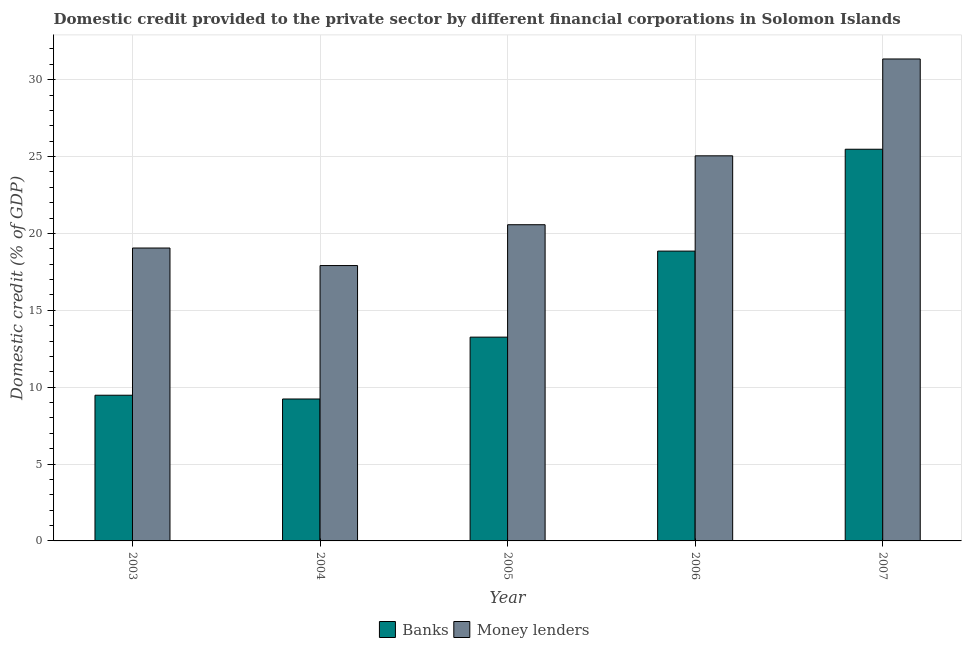How many groups of bars are there?
Offer a terse response. 5. How many bars are there on the 4th tick from the left?
Ensure brevity in your answer.  2. In how many cases, is the number of bars for a given year not equal to the number of legend labels?
Offer a terse response. 0. What is the domestic credit provided by money lenders in 2003?
Your answer should be compact. 19.05. Across all years, what is the maximum domestic credit provided by money lenders?
Give a very brief answer. 31.35. Across all years, what is the minimum domestic credit provided by banks?
Keep it short and to the point. 9.23. What is the total domestic credit provided by money lenders in the graph?
Provide a short and direct response. 113.93. What is the difference between the domestic credit provided by money lenders in 2004 and that in 2006?
Keep it short and to the point. -7.14. What is the difference between the domestic credit provided by money lenders in 2004 and the domestic credit provided by banks in 2007?
Offer a very short reply. -13.44. What is the average domestic credit provided by banks per year?
Provide a short and direct response. 15.26. What is the ratio of the domestic credit provided by banks in 2003 to that in 2007?
Give a very brief answer. 0.37. Is the domestic credit provided by banks in 2003 less than that in 2006?
Give a very brief answer. Yes. What is the difference between the highest and the second highest domestic credit provided by banks?
Your answer should be very brief. 6.63. What is the difference between the highest and the lowest domestic credit provided by banks?
Ensure brevity in your answer.  16.25. Is the sum of the domestic credit provided by banks in 2004 and 2007 greater than the maximum domestic credit provided by money lenders across all years?
Provide a succinct answer. Yes. What does the 2nd bar from the left in 2006 represents?
Provide a short and direct response. Money lenders. What does the 2nd bar from the right in 2007 represents?
Your response must be concise. Banks. How many bars are there?
Keep it short and to the point. 10. Are all the bars in the graph horizontal?
Your answer should be compact. No. Are the values on the major ticks of Y-axis written in scientific E-notation?
Your response must be concise. No. Does the graph contain grids?
Your answer should be compact. Yes. How many legend labels are there?
Provide a short and direct response. 2. How are the legend labels stacked?
Ensure brevity in your answer.  Horizontal. What is the title of the graph?
Provide a succinct answer. Domestic credit provided to the private sector by different financial corporations in Solomon Islands. What is the label or title of the Y-axis?
Make the answer very short. Domestic credit (% of GDP). What is the Domestic credit (% of GDP) of Banks in 2003?
Offer a very short reply. 9.48. What is the Domestic credit (% of GDP) of Money lenders in 2003?
Keep it short and to the point. 19.05. What is the Domestic credit (% of GDP) in Banks in 2004?
Your answer should be very brief. 9.23. What is the Domestic credit (% of GDP) of Money lenders in 2004?
Provide a short and direct response. 17.91. What is the Domestic credit (% of GDP) of Banks in 2005?
Your answer should be compact. 13.25. What is the Domestic credit (% of GDP) in Money lenders in 2005?
Your answer should be very brief. 20.57. What is the Domestic credit (% of GDP) in Banks in 2006?
Give a very brief answer. 18.85. What is the Domestic credit (% of GDP) of Money lenders in 2006?
Keep it short and to the point. 25.05. What is the Domestic credit (% of GDP) of Banks in 2007?
Ensure brevity in your answer.  25.48. What is the Domestic credit (% of GDP) in Money lenders in 2007?
Keep it short and to the point. 31.35. Across all years, what is the maximum Domestic credit (% of GDP) of Banks?
Make the answer very short. 25.48. Across all years, what is the maximum Domestic credit (% of GDP) in Money lenders?
Keep it short and to the point. 31.35. Across all years, what is the minimum Domestic credit (% of GDP) of Banks?
Your answer should be very brief. 9.23. Across all years, what is the minimum Domestic credit (% of GDP) in Money lenders?
Your answer should be compact. 17.91. What is the total Domestic credit (% of GDP) of Banks in the graph?
Provide a succinct answer. 76.29. What is the total Domestic credit (% of GDP) in Money lenders in the graph?
Provide a succinct answer. 113.93. What is the difference between the Domestic credit (% of GDP) of Banks in 2003 and that in 2004?
Ensure brevity in your answer.  0.25. What is the difference between the Domestic credit (% of GDP) in Money lenders in 2003 and that in 2004?
Offer a very short reply. 1.14. What is the difference between the Domestic credit (% of GDP) in Banks in 2003 and that in 2005?
Ensure brevity in your answer.  -3.78. What is the difference between the Domestic credit (% of GDP) in Money lenders in 2003 and that in 2005?
Your response must be concise. -1.52. What is the difference between the Domestic credit (% of GDP) of Banks in 2003 and that in 2006?
Give a very brief answer. -9.37. What is the difference between the Domestic credit (% of GDP) in Money lenders in 2003 and that in 2006?
Your answer should be very brief. -6. What is the difference between the Domestic credit (% of GDP) in Banks in 2003 and that in 2007?
Give a very brief answer. -16. What is the difference between the Domestic credit (% of GDP) of Money lenders in 2003 and that in 2007?
Provide a succinct answer. -12.3. What is the difference between the Domestic credit (% of GDP) in Banks in 2004 and that in 2005?
Provide a succinct answer. -4.02. What is the difference between the Domestic credit (% of GDP) of Money lenders in 2004 and that in 2005?
Offer a terse response. -2.66. What is the difference between the Domestic credit (% of GDP) in Banks in 2004 and that in 2006?
Ensure brevity in your answer.  -9.62. What is the difference between the Domestic credit (% of GDP) in Money lenders in 2004 and that in 2006?
Ensure brevity in your answer.  -7.14. What is the difference between the Domestic credit (% of GDP) of Banks in 2004 and that in 2007?
Make the answer very short. -16.25. What is the difference between the Domestic credit (% of GDP) of Money lenders in 2004 and that in 2007?
Give a very brief answer. -13.44. What is the difference between the Domestic credit (% of GDP) of Banks in 2005 and that in 2006?
Your response must be concise. -5.6. What is the difference between the Domestic credit (% of GDP) of Money lenders in 2005 and that in 2006?
Offer a terse response. -4.48. What is the difference between the Domestic credit (% of GDP) of Banks in 2005 and that in 2007?
Make the answer very short. -12.22. What is the difference between the Domestic credit (% of GDP) of Money lenders in 2005 and that in 2007?
Provide a short and direct response. -10.78. What is the difference between the Domestic credit (% of GDP) in Banks in 2006 and that in 2007?
Keep it short and to the point. -6.63. What is the difference between the Domestic credit (% of GDP) of Money lenders in 2006 and that in 2007?
Make the answer very short. -6.3. What is the difference between the Domestic credit (% of GDP) of Banks in 2003 and the Domestic credit (% of GDP) of Money lenders in 2004?
Make the answer very short. -8.43. What is the difference between the Domestic credit (% of GDP) in Banks in 2003 and the Domestic credit (% of GDP) in Money lenders in 2005?
Your answer should be compact. -11.09. What is the difference between the Domestic credit (% of GDP) of Banks in 2003 and the Domestic credit (% of GDP) of Money lenders in 2006?
Your response must be concise. -15.57. What is the difference between the Domestic credit (% of GDP) in Banks in 2003 and the Domestic credit (% of GDP) in Money lenders in 2007?
Keep it short and to the point. -21.87. What is the difference between the Domestic credit (% of GDP) in Banks in 2004 and the Domestic credit (% of GDP) in Money lenders in 2005?
Provide a short and direct response. -11.34. What is the difference between the Domestic credit (% of GDP) in Banks in 2004 and the Domestic credit (% of GDP) in Money lenders in 2006?
Your answer should be compact. -15.82. What is the difference between the Domestic credit (% of GDP) of Banks in 2004 and the Domestic credit (% of GDP) of Money lenders in 2007?
Keep it short and to the point. -22.12. What is the difference between the Domestic credit (% of GDP) of Banks in 2005 and the Domestic credit (% of GDP) of Money lenders in 2006?
Your answer should be compact. -11.79. What is the difference between the Domestic credit (% of GDP) of Banks in 2005 and the Domestic credit (% of GDP) of Money lenders in 2007?
Offer a terse response. -18.09. What is the difference between the Domestic credit (% of GDP) in Banks in 2006 and the Domestic credit (% of GDP) in Money lenders in 2007?
Keep it short and to the point. -12.5. What is the average Domestic credit (% of GDP) of Banks per year?
Provide a short and direct response. 15.26. What is the average Domestic credit (% of GDP) of Money lenders per year?
Your response must be concise. 22.79. In the year 2003, what is the difference between the Domestic credit (% of GDP) of Banks and Domestic credit (% of GDP) of Money lenders?
Provide a short and direct response. -9.58. In the year 2004, what is the difference between the Domestic credit (% of GDP) of Banks and Domestic credit (% of GDP) of Money lenders?
Your answer should be compact. -8.68. In the year 2005, what is the difference between the Domestic credit (% of GDP) in Banks and Domestic credit (% of GDP) in Money lenders?
Your answer should be very brief. -7.31. In the year 2006, what is the difference between the Domestic credit (% of GDP) in Banks and Domestic credit (% of GDP) in Money lenders?
Your answer should be compact. -6.2. In the year 2007, what is the difference between the Domestic credit (% of GDP) in Banks and Domestic credit (% of GDP) in Money lenders?
Ensure brevity in your answer.  -5.87. What is the ratio of the Domestic credit (% of GDP) in Banks in 2003 to that in 2004?
Ensure brevity in your answer.  1.03. What is the ratio of the Domestic credit (% of GDP) of Money lenders in 2003 to that in 2004?
Your answer should be compact. 1.06. What is the ratio of the Domestic credit (% of GDP) of Banks in 2003 to that in 2005?
Offer a very short reply. 0.71. What is the ratio of the Domestic credit (% of GDP) in Money lenders in 2003 to that in 2005?
Your response must be concise. 0.93. What is the ratio of the Domestic credit (% of GDP) of Banks in 2003 to that in 2006?
Give a very brief answer. 0.5. What is the ratio of the Domestic credit (% of GDP) of Money lenders in 2003 to that in 2006?
Provide a succinct answer. 0.76. What is the ratio of the Domestic credit (% of GDP) of Banks in 2003 to that in 2007?
Your answer should be very brief. 0.37. What is the ratio of the Domestic credit (% of GDP) of Money lenders in 2003 to that in 2007?
Provide a short and direct response. 0.61. What is the ratio of the Domestic credit (% of GDP) in Banks in 2004 to that in 2005?
Provide a short and direct response. 0.7. What is the ratio of the Domestic credit (% of GDP) in Money lenders in 2004 to that in 2005?
Your response must be concise. 0.87. What is the ratio of the Domestic credit (% of GDP) of Banks in 2004 to that in 2006?
Keep it short and to the point. 0.49. What is the ratio of the Domestic credit (% of GDP) of Money lenders in 2004 to that in 2006?
Offer a terse response. 0.72. What is the ratio of the Domestic credit (% of GDP) of Banks in 2004 to that in 2007?
Offer a very short reply. 0.36. What is the ratio of the Domestic credit (% of GDP) of Money lenders in 2004 to that in 2007?
Ensure brevity in your answer.  0.57. What is the ratio of the Domestic credit (% of GDP) in Banks in 2005 to that in 2006?
Your answer should be compact. 0.7. What is the ratio of the Domestic credit (% of GDP) in Money lenders in 2005 to that in 2006?
Keep it short and to the point. 0.82. What is the ratio of the Domestic credit (% of GDP) of Banks in 2005 to that in 2007?
Offer a very short reply. 0.52. What is the ratio of the Domestic credit (% of GDP) in Money lenders in 2005 to that in 2007?
Offer a very short reply. 0.66. What is the ratio of the Domestic credit (% of GDP) of Banks in 2006 to that in 2007?
Your answer should be compact. 0.74. What is the ratio of the Domestic credit (% of GDP) of Money lenders in 2006 to that in 2007?
Give a very brief answer. 0.8. What is the difference between the highest and the second highest Domestic credit (% of GDP) in Banks?
Your answer should be compact. 6.63. What is the difference between the highest and the second highest Domestic credit (% of GDP) in Money lenders?
Make the answer very short. 6.3. What is the difference between the highest and the lowest Domestic credit (% of GDP) in Banks?
Provide a short and direct response. 16.25. What is the difference between the highest and the lowest Domestic credit (% of GDP) of Money lenders?
Your answer should be compact. 13.44. 